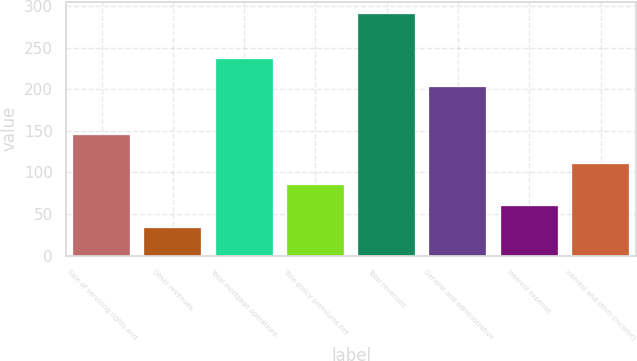Convert chart. <chart><loc_0><loc_0><loc_500><loc_500><bar_chart><fcel>Sale of servicing rights and<fcel>Other revenues<fcel>Total mortgage operations<fcel>Title policy premiums net<fcel>Total revenues<fcel>General and administrative<fcel>Interest expense<fcel>Interest and other (income)<nl><fcel>145.5<fcel>33.5<fcel>236.6<fcel>84.96<fcel>290.8<fcel>202.2<fcel>59.23<fcel>110.69<nl></chart> 